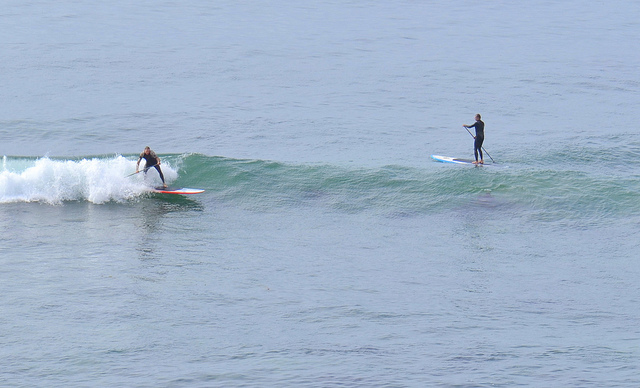<image>Is the water cold? I don't know if the water is cold or not. Is the water cold? I don't know if the water is cold. It can be both cold and not cold. 